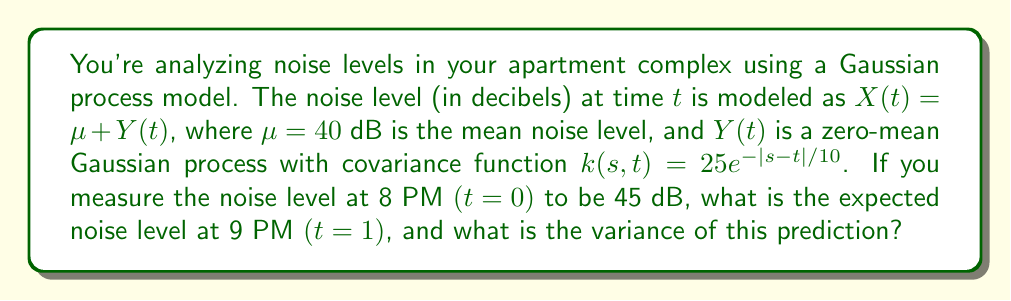Provide a solution to this math problem. Let's approach this step-by-step:

1) We're dealing with a Gaussian process $X(t)$ with mean $\mu = 40$ dB and covariance function $k(s,t) = 25e^{-|s-t|/10}$.

2) We've observed $X(0) = 45$ dB at 8 PM, and we want to predict $X(1)$ at 9 PM.

3) For Gaussian processes, the best predictor is the conditional expectation, given by:

   $$E[X(1)|X(0)=45] = \mu + \frac{k(0,1)}{k(0,0)}(X(0) - \mu)$$

4) Let's calculate each component:
   - $\mu = 40$
   - $k(0,1) = 25e^{-|0-1|/10} = 25e^{-0.1} \approx 22.54$
   - $k(0,0) = 25e^{-|0-0|/10} = 25$
   - $X(0) - \mu = 45 - 40 = 5$

5) Substituting these values:

   $$E[X(1)|X(0)=45] = 40 + \frac{22.54}{25}(5) \approx 44.51$$

6) For the variance of the prediction, we use:

   $$Var[X(1)|X(0)] = k(1,1) - \frac{k(0,1)^2}{k(0,0)}$$

7) We already know $k(0,1)$ and $k(0,0)$. $k(1,1) = 25$ (same as $k(0,0)$).

8) Substituting:

   $$Var[X(1)|X(0)] = 25 - \frac{22.54^2}{25} \approx 4.69$$
Answer: Expected noise level at 9 PM: 44.51 dB; Variance: 4.69 dB² 